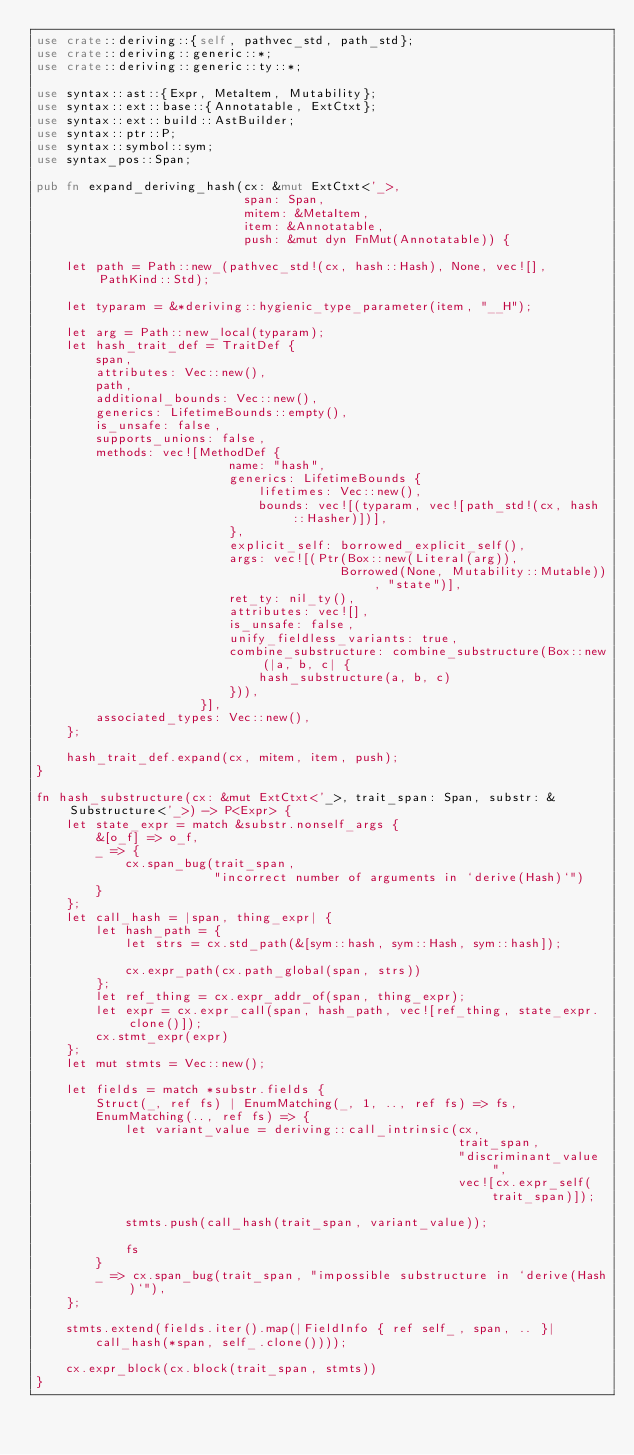Convert code to text. <code><loc_0><loc_0><loc_500><loc_500><_Rust_>use crate::deriving::{self, pathvec_std, path_std};
use crate::deriving::generic::*;
use crate::deriving::generic::ty::*;

use syntax::ast::{Expr, MetaItem, Mutability};
use syntax::ext::base::{Annotatable, ExtCtxt};
use syntax::ext::build::AstBuilder;
use syntax::ptr::P;
use syntax::symbol::sym;
use syntax_pos::Span;

pub fn expand_deriving_hash(cx: &mut ExtCtxt<'_>,
                            span: Span,
                            mitem: &MetaItem,
                            item: &Annotatable,
                            push: &mut dyn FnMut(Annotatable)) {

    let path = Path::new_(pathvec_std!(cx, hash::Hash), None, vec![], PathKind::Std);

    let typaram = &*deriving::hygienic_type_parameter(item, "__H");

    let arg = Path::new_local(typaram);
    let hash_trait_def = TraitDef {
        span,
        attributes: Vec::new(),
        path,
        additional_bounds: Vec::new(),
        generics: LifetimeBounds::empty(),
        is_unsafe: false,
        supports_unions: false,
        methods: vec![MethodDef {
                          name: "hash",
                          generics: LifetimeBounds {
                              lifetimes: Vec::new(),
                              bounds: vec![(typaram, vec![path_std!(cx, hash::Hasher)])],
                          },
                          explicit_self: borrowed_explicit_self(),
                          args: vec![(Ptr(Box::new(Literal(arg)),
                                         Borrowed(None, Mutability::Mutable)), "state")],
                          ret_ty: nil_ty(),
                          attributes: vec![],
                          is_unsafe: false,
                          unify_fieldless_variants: true,
                          combine_substructure: combine_substructure(Box::new(|a, b, c| {
                              hash_substructure(a, b, c)
                          })),
                      }],
        associated_types: Vec::new(),
    };

    hash_trait_def.expand(cx, mitem, item, push);
}

fn hash_substructure(cx: &mut ExtCtxt<'_>, trait_span: Span, substr: &Substructure<'_>) -> P<Expr> {
    let state_expr = match &substr.nonself_args {
        &[o_f] => o_f,
        _ => {
            cx.span_bug(trait_span,
                        "incorrect number of arguments in `derive(Hash)`")
        }
    };
    let call_hash = |span, thing_expr| {
        let hash_path = {
            let strs = cx.std_path(&[sym::hash, sym::Hash, sym::hash]);

            cx.expr_path(cx.path_global(span, strs))
        };
        let ref_thing = cx.expr_addr_of(span, thing_expr);
        let expr = cx.expr_call(span, hash_path, vec![ref_thing, state_expr.clone()]);
        cx.stmt_expr(expr)
    };
    let mut stmts = Vec::new();

    let fields = match *substr.fields {
        Struct(_, ref fs) | EnumMatching(_, 1, .., ref fs) => fs,
        EnumMatching(.., ref fs) => {
            let variant_value = deriving::call_intrinsic(cx,
                                                         trait_span,
                                                         "discriminant_value",
                                                         vec![cx.expr_self(trait_span)]);

            stmts.push(call_hash(trait_span, variant_value));

            fs
        }
        _ => cx.span_bug(trait_span, "impossible substructure in `derive(Hash)`"),
    };

    stmts.extend(fields.iter().map(|FieldInfo { ref self_, span, .. }|
        call_hash(*span, self_.clone())));

    cx.expr_block(cx.block(trait_span, stmts))
}
</code> 